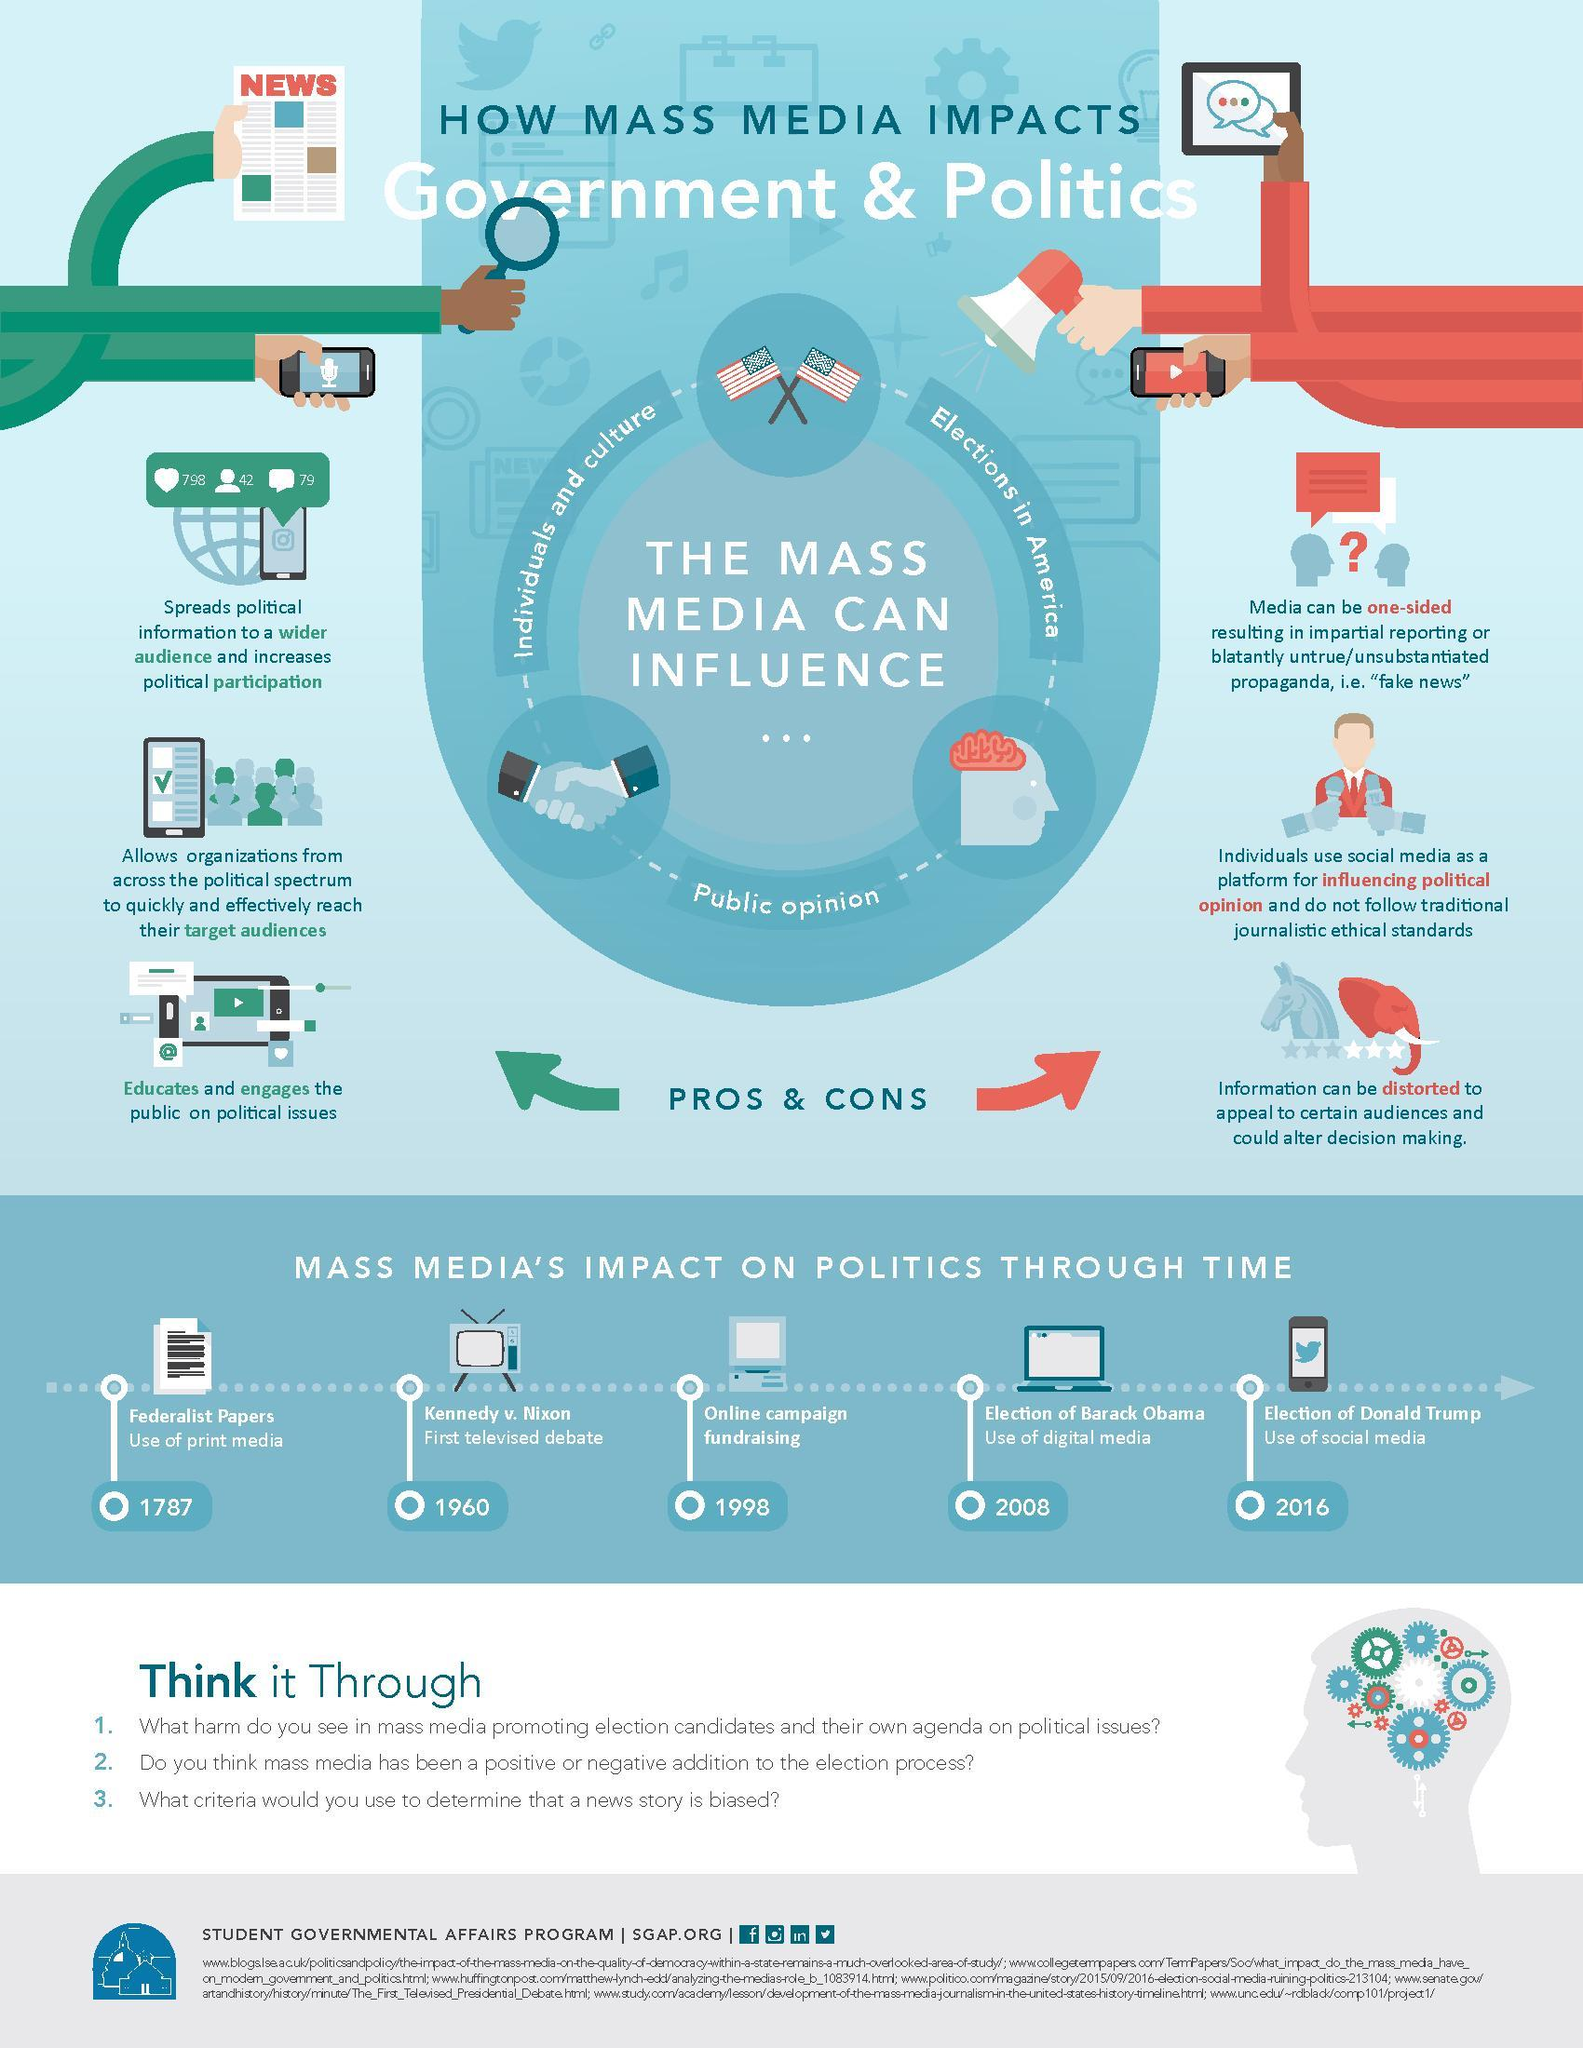When did Federalist papers started using print media?
Answer the question with a short phrase. 1787 When was the first televised presidential debate in American history? 1960 